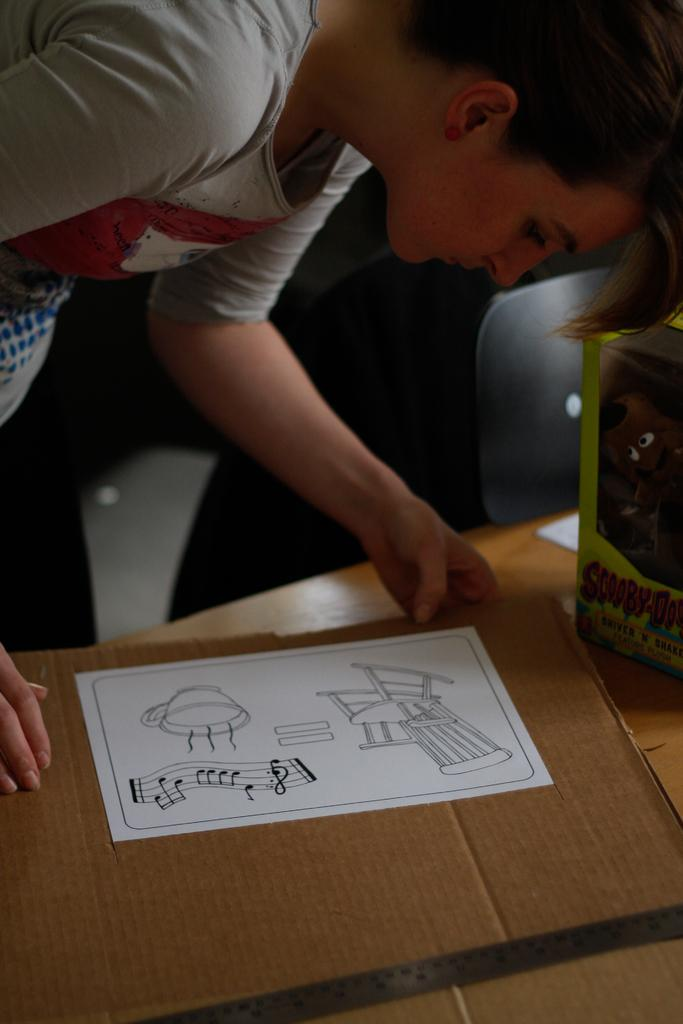Who is present in the image? There is a woman in the image. What is the woman holding in the image? The woman is holding a cardboard. Can you describe the cardboard? There is a paper with some drawing on the cardboard. What can be seen in the background of the image? There is a doll placed in a box and a chair in the background. What is the position of the road in the image? There is no road present in the image. 